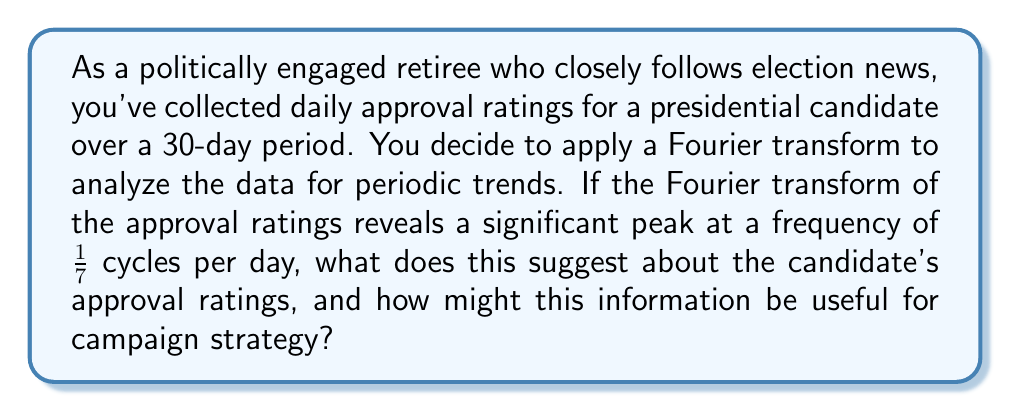Can you solve this math problem? To understand this problem, let's break it down step-by-step:

1) The Fourier transform is a mathematical tool that decomposes a function of time into its constituent frequencies. In this case, we're applying it to the candidate's approval ratings over time.

2) The Fourier transform is given by:

   $$F(\omega) = \int_{-\infty}^{\infty} f(t) e^{-i\omega t} dt$$

   Where $f(t)$ is the approval rating function over time, and $F(\omega)$ is the Fourier transform.

3) A peak in the Fourier transform at a particular frequency indicates a strong periodic component at that frequency in the original data.

4) In this case, we see a significant peak at a frequency of 1/7 cycles per day. To interpret this:

   $$\text{Period} = \frac{1}{\text{Frequency}} = \frac{1}{1/7} = 7 \text{ days}$$

5) This suggests that there is a strong weekly (7-day) cycle in the candidate's approval ratings.

6) Possible explanations for this weekly cycle could include:
   - Weekly news cycles affecting public opinion
   - Regular weekly campaign activities or events
   - Weekend vs. weekday differences in public sentiment

7) This information could be useful for campaign strategy in several ways:
   - Timing important announcements or events to coincide with peaks in approval
   - Scheduling damage control or positive messaging to counteract predictable dips
   - Understanding the rhythm of public opinion to better pace campaign activities

8) For a politically active retiree following cable news, this analysis provides insight into the underlying patterns of public opinion that may not be immediately apparent from day-to-day reporting.
Answer: A significant peak at a frequency of 1/7 cycles per day in the Fourier transform suggests a strong weekly (7-day) cycle in the candidate's approval ratings. This information could be used to optimize the timing of campaign events, manage messaging, and understand the rhythm of public opinion in relation to weekly news cycles. 